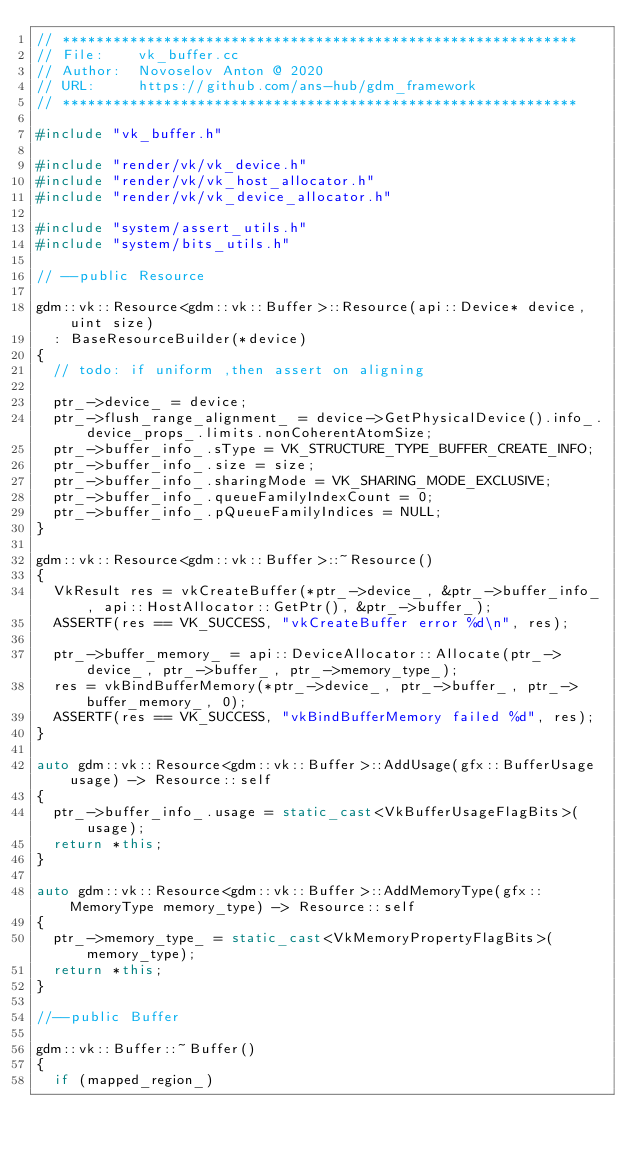Convert code to text. <code><loc_0><loc_0><loc_500><loc_500><_C++_>// *************************************************************
// File:    vk_buffer.cc
// Author:  Novoselov Anton @ 2020
// URL:     https://github.com/ans-hub/gdm_framework
// *************************************************************

#include "vk_buffer.h"

#include "render/vk/vk_device.h"
#include "render/vk/vk_host_allocator.h"
#include "render/vk/vk_device_allocator.h"

#include "system/assert_utils.h"
#include "system/bits_utils.h"

// --public Resource

gdm::vk::Resource<gdm::vk::Buffer>::Resource(api::Device* device, uint size)
  : BaseResourceBuilder(*device)
{
  // todo: if uniform ,then assert on aligning

  ptr_->device_ = device;
  ptr_->flush_range_alignment_ = device->GetPhysicalDevice().info_.device_props_.limits.nonCoherentAtomSize;
  ptr_->buffer_info_.sType = VK_STRUCTURE_TYPE_BUFFER_CREATE_INFO;
  ptr_->buffer_info_.size = size;
  ptr_->buffer_info_.sharingMode = VK_SHARING_MODE_EXCLUSIVE;
  ptr_->buffer_info_.queueFamilyIndexCount = 0;
  ptr_->buffer_info_.pQueueFamilyIndices = NULL;
}

gdm::vk::Resource<gdm::vk::Buffer>::~Resource()
{
  VkResult res = vkCreateBuffer(*ptr_->device_, &ptr_->buffer_info_, api::HostAllocator::GetPtr(), &ptr_->buffer_);
  ASSERTF(res == VK_SUCCESS, "vkCreateBuffer error %d\n", res);
 
  ptr_->buffer_memory_ = api::DeviceAllocator::Allocate(ptr_->device_, ptr_->buffer_, ptr_->memory_type_);
  res = vkBindBufferMemory(*ptr_->device_, ptr_->buffer_, ptr_->buffer_memory_, 0);
  ASSERTF(res == VK_SUCCESS, "vkBindBufferMemory failed %d", res);
}

auto gdm::vk::Resource<gdm::vk::Buffer>::AddUsage(gfx::BufferUsage usage) -> Resource::self
{
  ptr_->buffer_info_.usage = static_cast<VkBufferUsageFlagBits>(usage);
  return *this;
}

auto gdm::vk::Resource<gdm::vk::Buffer>::AddMemoryType(gfx::MemoryType memory_type) -> Resource::self
{
  ptr_->memory_type_ = static_cast<VkMemoryPropertyFlagBits>(memory_type);
  return *this;
}

//--public Buffer

gdm::vk::Buffer::~Buffer()
{
  if (mapped_region_)</code> 